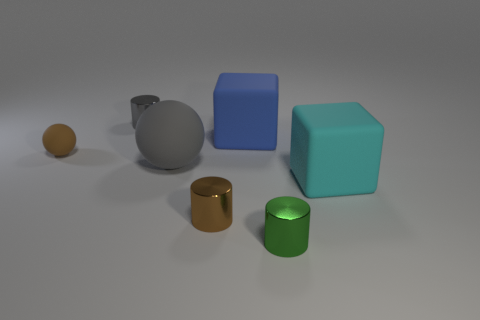Add 1 gray blocks. How many objects exist? 8 Subtract all cylinders. How many objects are left? 4 Subtract 0 purple spheres. How many objects are left? 7 Subtract all big red cylinders. Subtract all tiny matte objects. How many objects are left? 6 Add 6 big gray things. How many big gray things are left? 7 Add 5 big brown metal blocks. How many big brown metal blocks exist? 5 